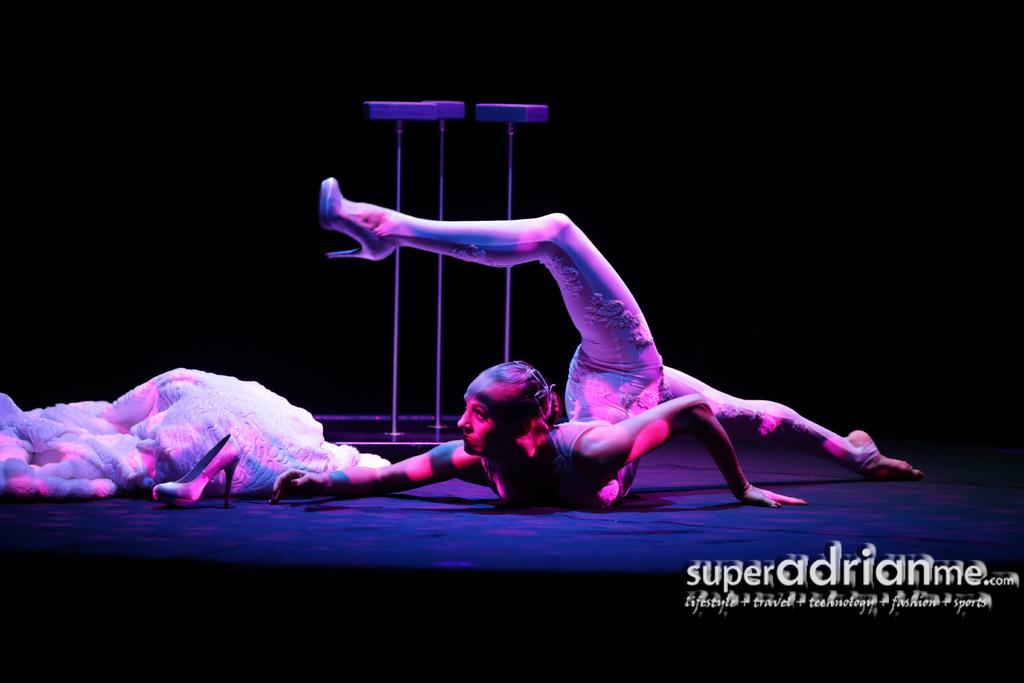Who is present in the image? There is a woman in the image. What can be seen on the woman's body? Clothing and footwear are visible in the image. What else can be seen in the image besides the woman? Objects are present in the image. How would you describe the background of the image? The background of the image is dark. Where is the text located in the image? The text is in the bottom right side of the image. What type of school is depicted in the image? There is no school present in the image; it features a woman with clothing, footwear, and text in the bottom right side of the image. How does the woman's love for her pet affect the image? There is no indication of a pet or love for a pet in the image, so it cannot be determined how it might affect the image. 